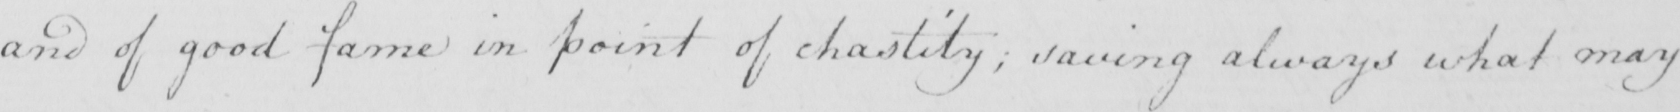What text is written in this handwritten line? and of good fame in point of chastity ; saving always what may 